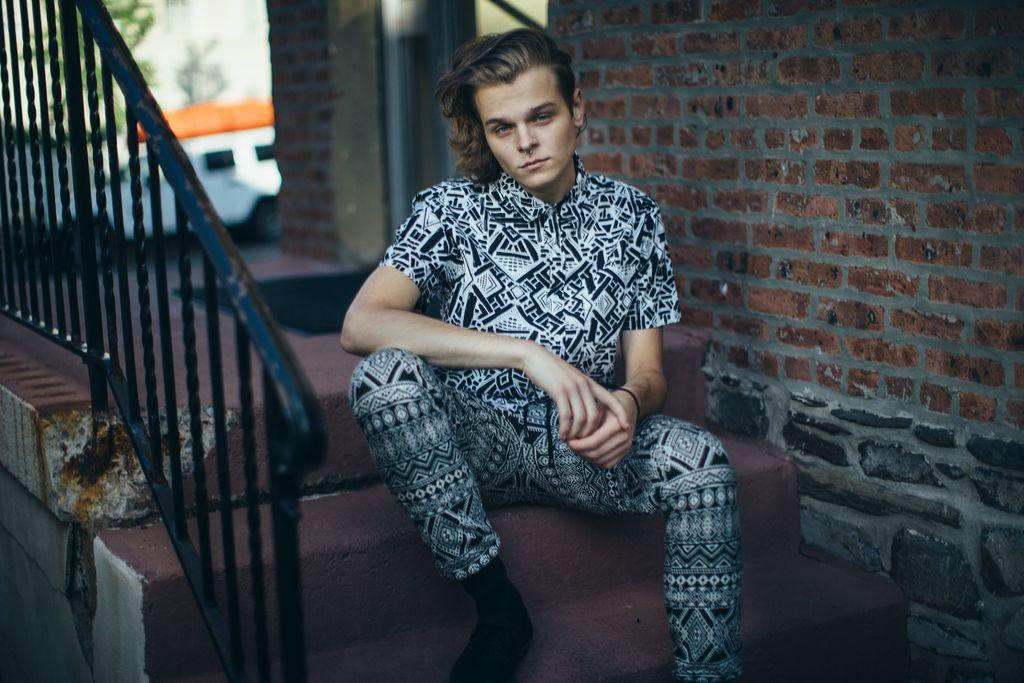What is the person in the image doing? The person is sitting on a staircase. What can be seen on the left side of the image? There is a fence visible on the left side of the image. What is on the right side of the image? There is a wall visible on the right side of the image. What is in the middle of the image? A vehicle is visible in the middle of the image. What type of toothpaste is the person using in the image? There is no toothpaste present in the image; the person is sitting on a staircase. What hour of the day is depicted in the image? The provided facts do not give any information about the time of day, so it cannot be determined from the image. 